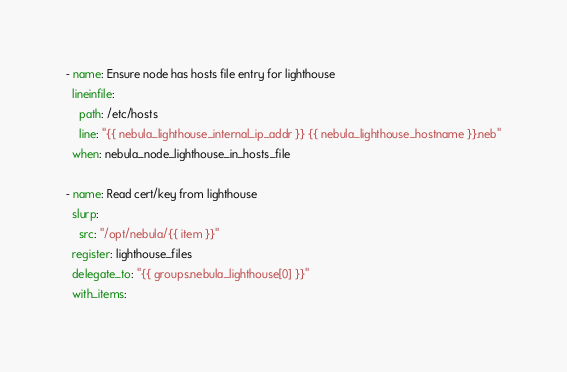<code> <loc_0><loc_0><loc_500><loc_500><_YAML_>- name: Ensure node has hosts file entry for lighthouse
  lineinfile:
    path: /etc/hosts
    line: "{{ nebula_lighthouse_internal_ip_addr }} {{ nebula_lighthouse_hostname }}.neb"
  when: nebula_node_lighthouse_in_hosts_file

- name: Read cert/key from lighthouse
  slurp:
    src: "/opt/nebula/{{ item }}"
  register: lighthouse_files
  delegate_to: "{{ groups.nebula_lighthouse[0] }}"
  with_items: </code> 